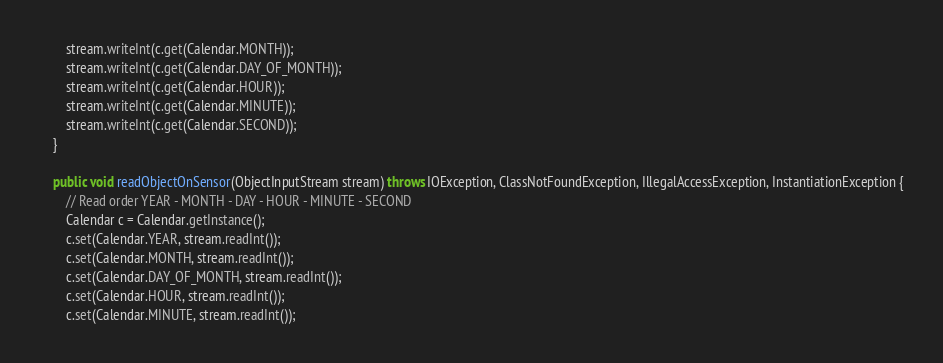<code> <loc_0><loc_0><loc_500><loc_500><_Java_>        stream.writeInt(c.get(Calendar.MONTH));
        stream.writeInt(c.get(Calendar.DAY_OF_MONTH));
        stream.writeInt(c.get(Calendar.HOUR));
        stream.writeInt(c.get(Calendar.MINUTE));
        stream.writeInt(c.get(Calendar.SECOND));
    }

    public void readObjectOnSensor(ObjectInputStream stream) throws IOException, ClassNotFoundException, IllegalAccessException, InstantiationException {
        // Read order YEAR - MONTH - DAY - HOUR - MINUTE - SECOND
        Calendar c = Calendar.getInstance();
        c.set(Calendar.YEAR, stream.readInt());
        c.set(Calendar.MONTH, stream.readInt());
        c.set(Calendar.DAY_OF_MONTH, stream.readInt());
        c.set(Calendar.HOUR, stream.readInt());
        c.set(Calendar.MINUTE, stream.readInt());</code> 